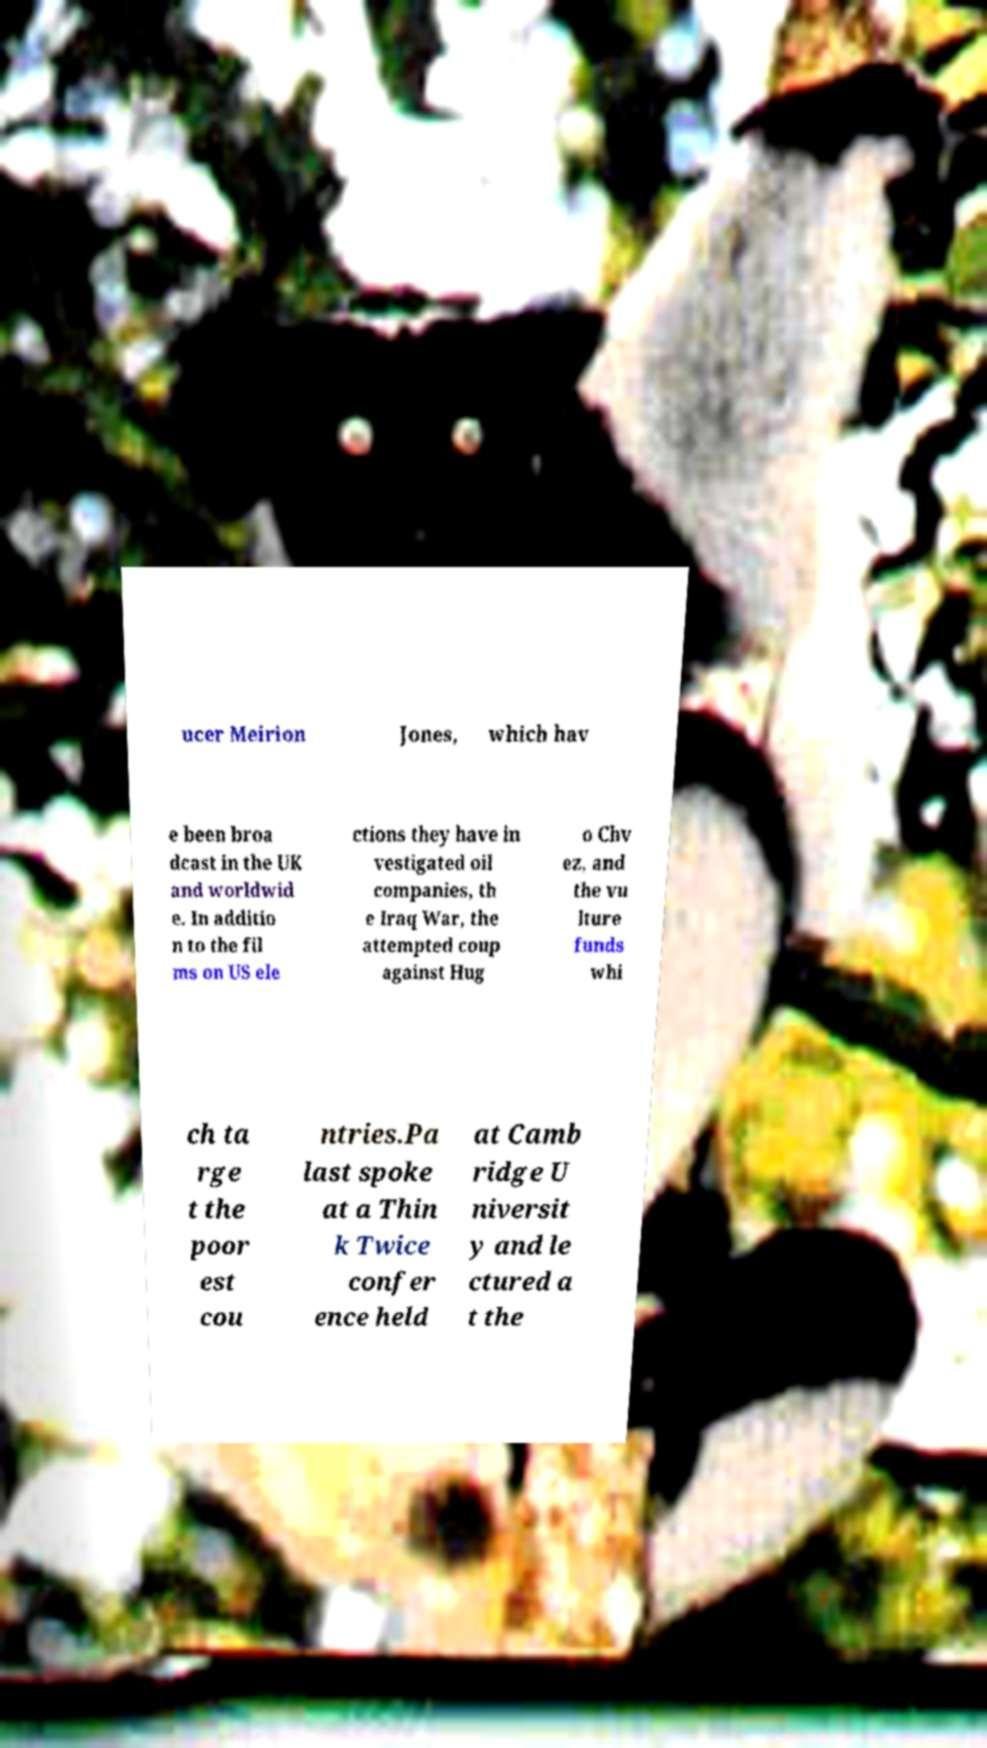For documentation purposes, I need the text within this image transcribed. Could you provide that? ucer Meirion Jones, which hav e been broa dcast in the UK and worldwid e. In additio n to the fil ms on US ele ctions they have in vestigated oil companies, th e Iraq War, the attempted coup against Hug o Chv ez, and the vu lture funds whi ch ta rge t the poor est cou ntries.Pa last spoke at a Thin k Twice confer ence held at Camb ridge U niversit y and le ctured a t the 